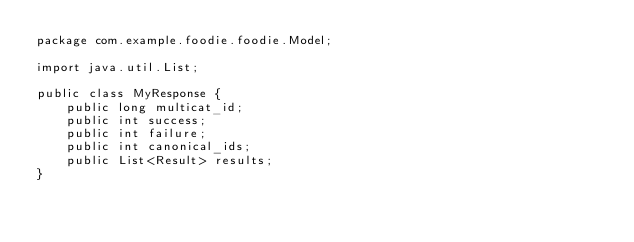Convert code to text. <code><loc_0><loc_0><loc_500><loc_500><_Java_>package com.example.foodie.foodie.Model;

import java.util.List;

public class MyResponse {
    public long multicat_id;
    public int success;
    public int failure;
    public int canonical_ids;
    public List<Result> results;
}
</code> 